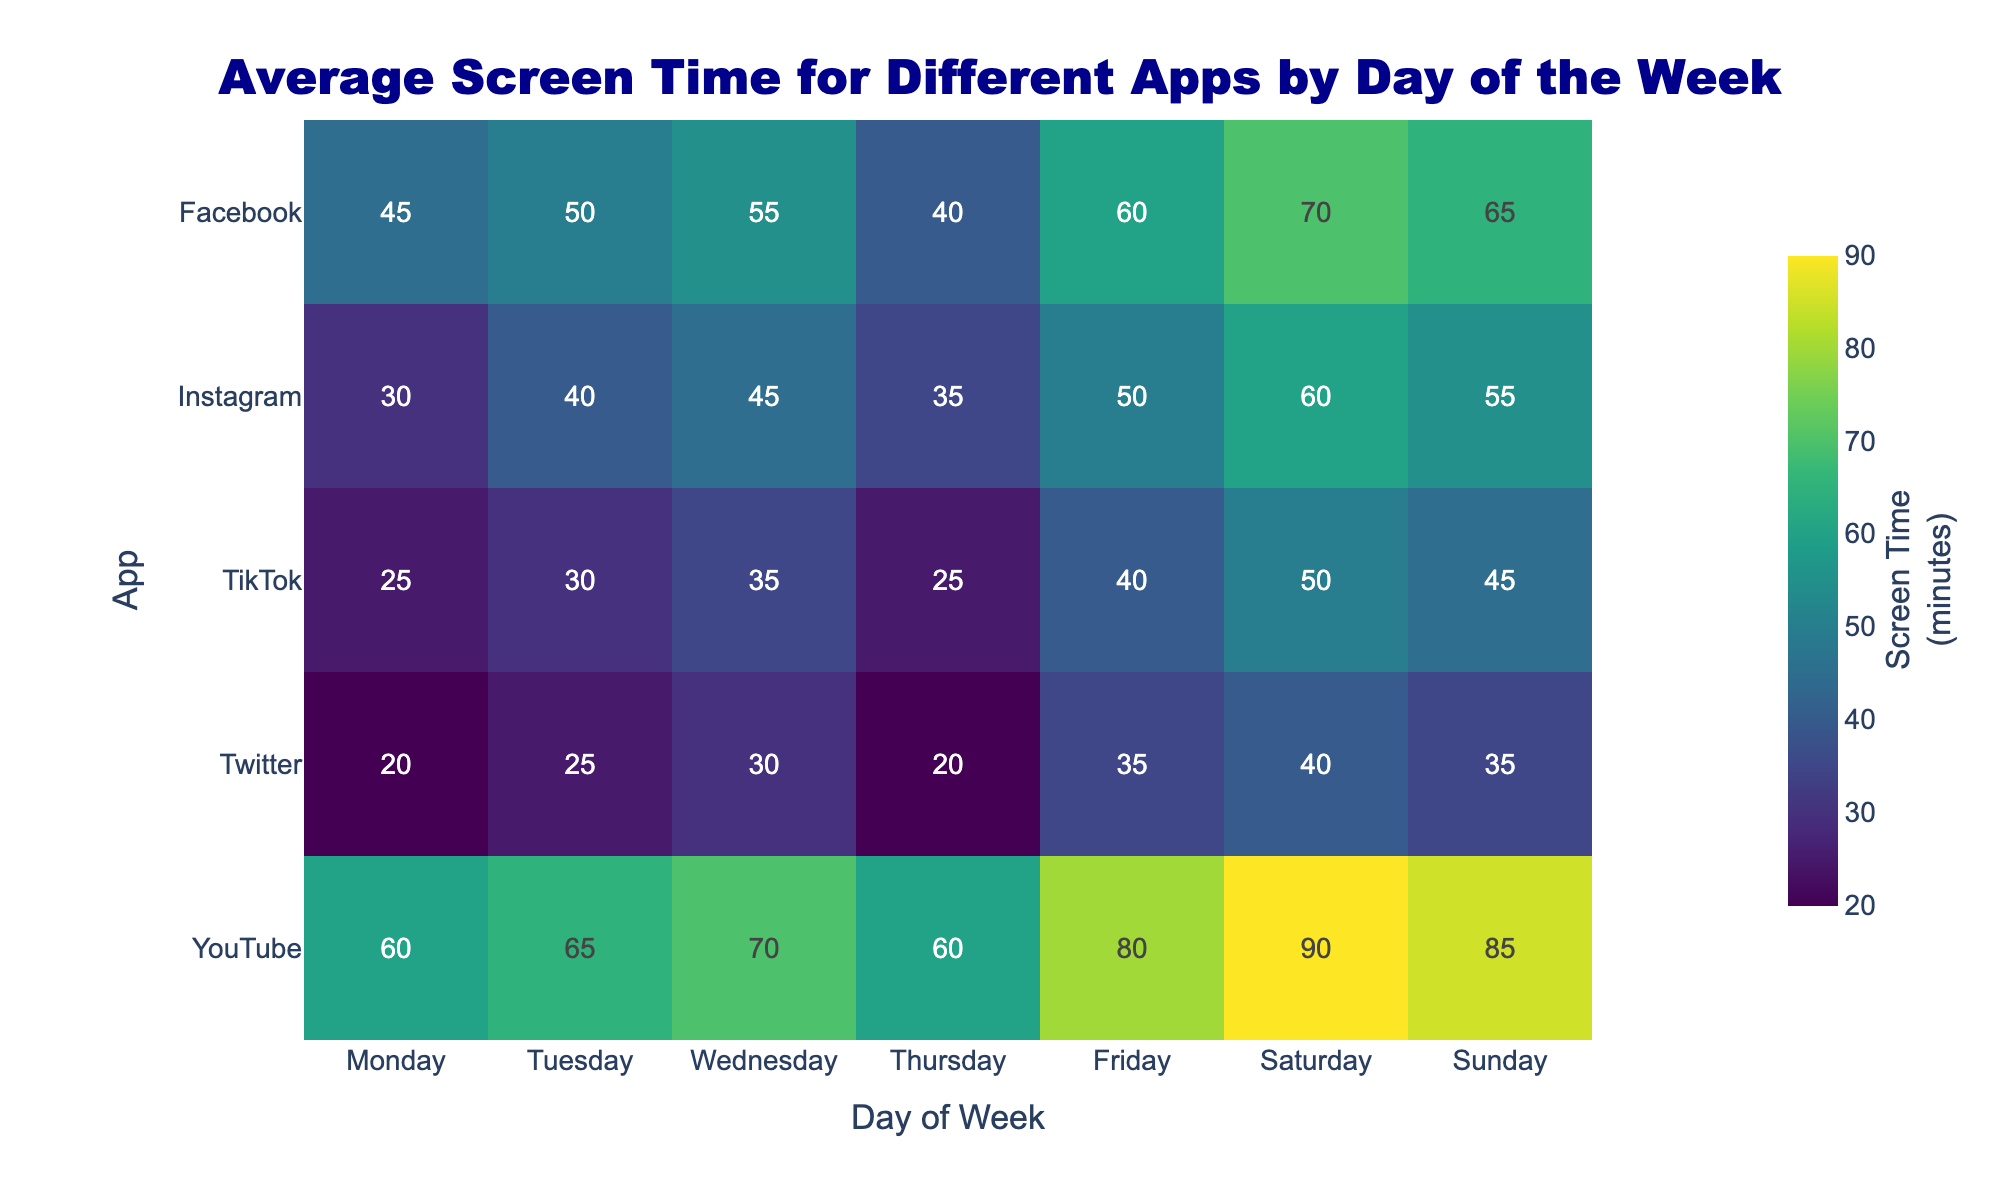What does the title of the heatmap say? The title of the heatmap is clearly displayed at the top of the figure. It states what the figure is about, providing context for the data shown.
Answer: Average Screen Time for Different Apps by Day of the Week Which app has the highest average screen time on Saturday? To find the highest average screen time on Saturday, look for the darkest color in the Saturday column of the heatmap, which indicates the most screen time.
Answer: YouTube On which day is screen time the lowest for Instagram? Check the Instagram row and look for the lightest color, which represents the least screen time, and identify the day on the x-axis.
Answer: Monday Compare the screen time for Facebook on Tuesday and on Friday. Which day has more screen time? Locate the Tuesday and Friday columns in the Facebook row and compare the shades of colors between the two days. The color closer to the darkest shade has more screen time.
Answer: Friday What is the total screen time for Twitter from Monday to Sunday? Add up the screen time values for Twitter across all days of the week as shown in the Twitter row: 20 + 25 + 30 + 20 + 35 + 40 + 35.
Answer: 205 Identify the app with the most consistent screen time across all days of the week. Consistent screen time would be indicated by similar color shades across all days in a particular row. Compare the rows to see which one has the least range of different colors.
Answer: Twitter Which two apps have the exact same screen time on Sunday? Look at the Sunday column and identify any two rows (apps) with the same color shade, corresponding to the same numeric value.
Answer: TikTok and Twitter How does YouTube's screen time on Wednesday compare to that on Saturday? Look at the Wednesday and Saturday columns for YouTube. Identify which day has the darker shade, which signifies more screen time, using the color intensity.
Answer: Saturday By how many minutes is the screen time on Friday for TikTok higher than on Monday? Subtract the screen time for Monday from the screen time for Friday for TikTok. That is 40 (Friday) - 25 (Monday).
Answer: 15 Which day of the week has the highest total screen time across all apps? Sum the screen times for each app on each day and compare the totals. This involves adding the values in each column and finding the highest total.
Answer: Saturday 